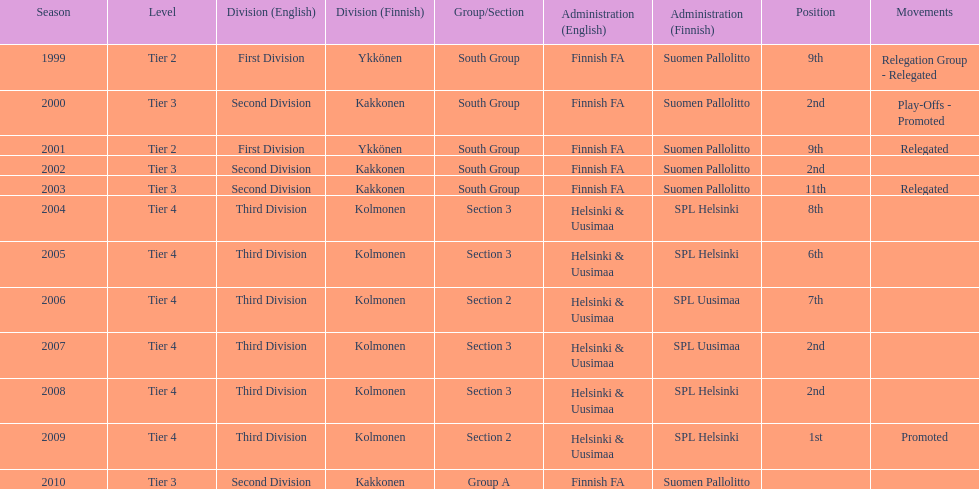Which was the only kolmonen whose movements were promoted? 2009. 